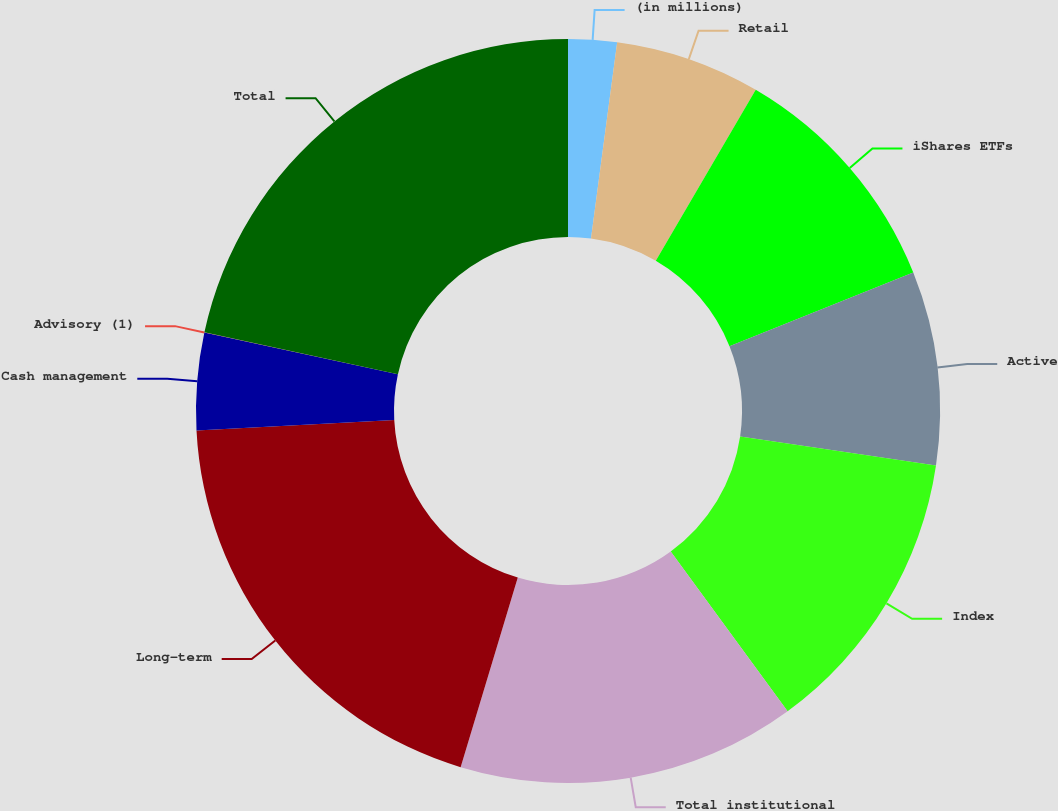<chart> <loc_0><loc_0><loc_500><loc_500><pie_chart><fcel>(in millions)<fcel>Retail<fcel>iShares ETFs<fcel>Active<fcel>Index<fcel>Total institutional<fcel>Long-term<fcel>Cash management<fcel>Advisory (1)<fcel>Total<nl><fcel>2.11%<fcel>6.31%<fcel>10.51%<fcel>8.41%<fcel>12.61%<fcel>14.71%<fcel>19.51%<fcel>4.21%<fcel>0.01%<fcel>21.61%<nl></chart> 